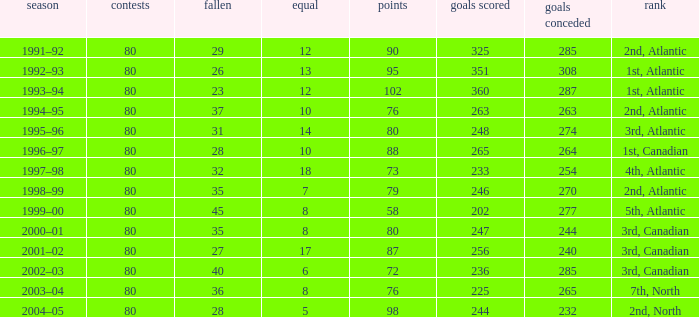How many goals against have 58 points? 277.0. 